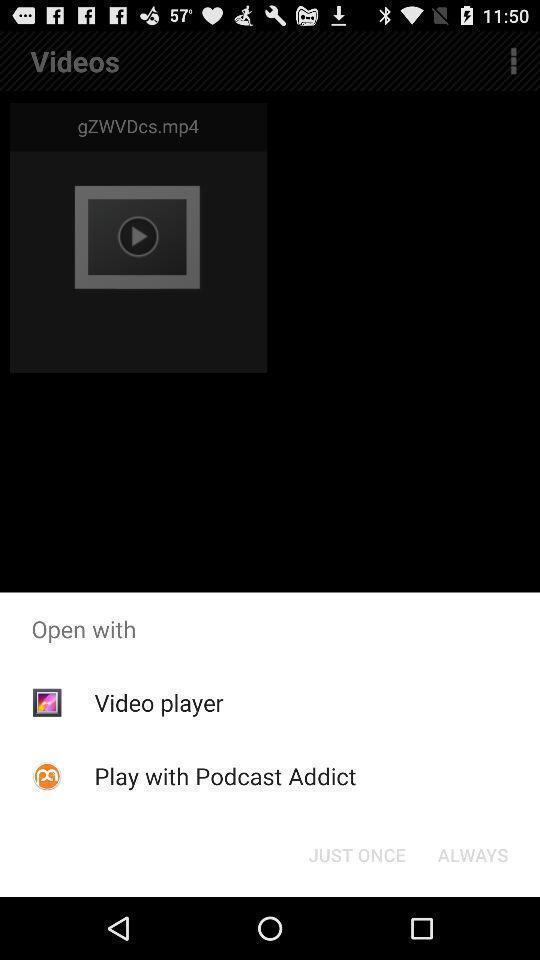What details can you identify in this image? Popup to open video in the gallery application. 